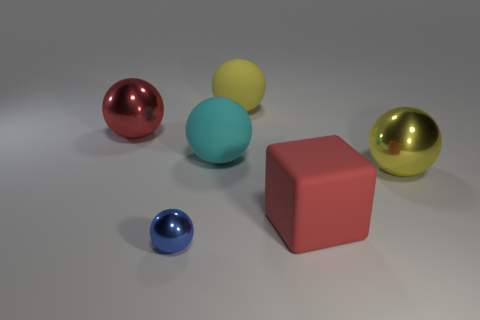Can you describe the lighting in the scene? The lighting in the image seems to be soft and diffused, casting gentle shadows on the floor beneath the objects. It appears to be coming from above, suggesting a single or multiple light sources out of view, possibly mimicking an indoor environment. 